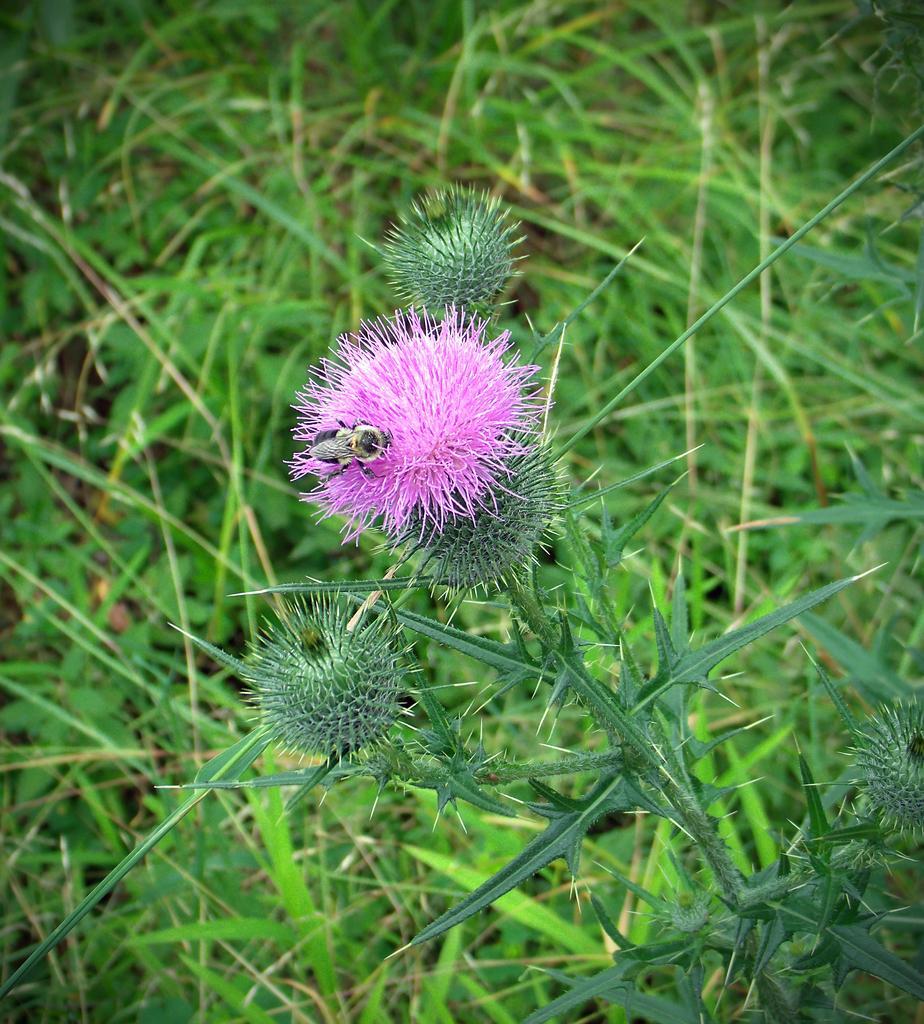Describe this image in one or two sentences. This is a zoomed in picture which is clicked outside. In the center there is a fly on the pink color object seems to be the flower and we can see the plant. In the background we can the grass and the ground. 